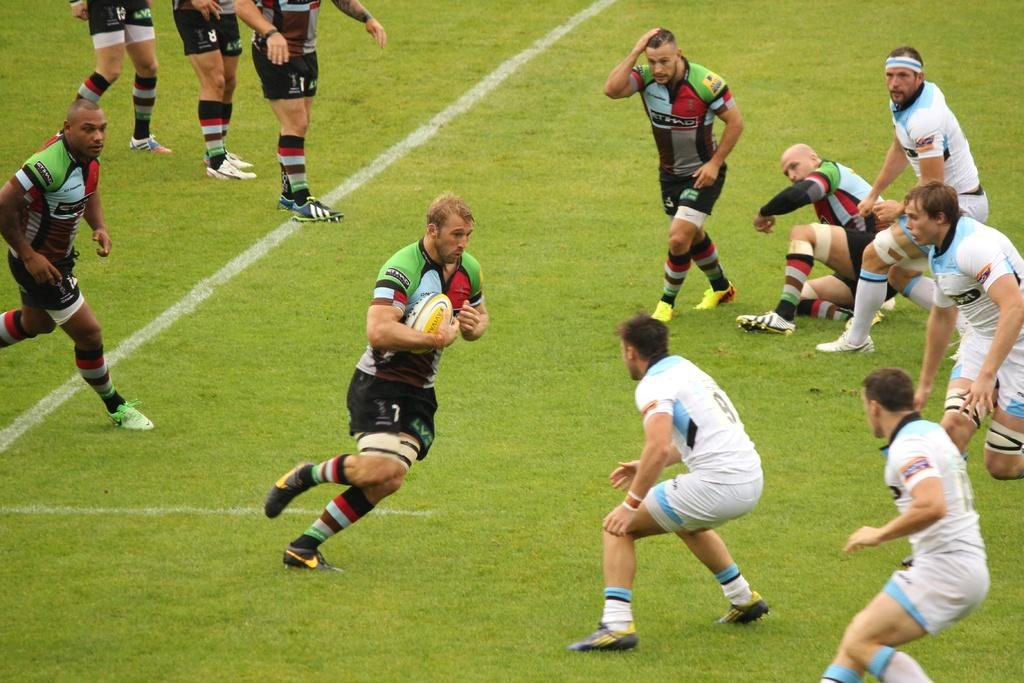<image>
Give a short and clear explanation of the subsequent image. An athlete holding a ball runs toward another athlete wearing a 9 on the back of his jersey. 